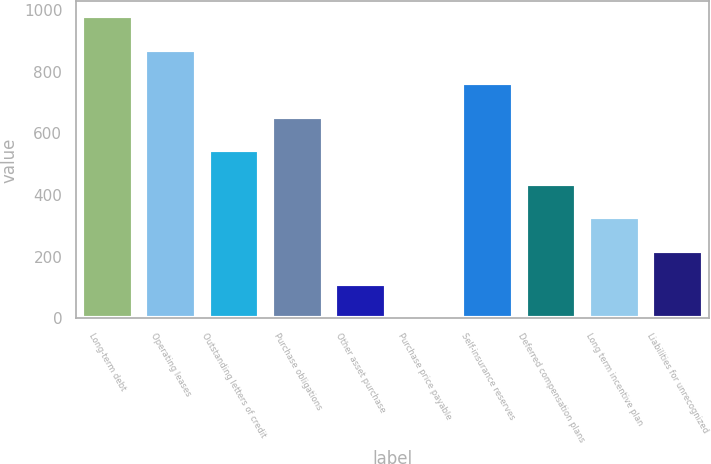Convert chart. <chart><loc_0><loc_0><loc_500><loc_500><bar_chart><fcel>Long-term debt<fcel>Operating leases<fcel>Outstanding letters of credit<fcel>Purchase obligations<fcel>Other asset purchase<fcel>Purchase price payable<fcel>Self-insurance reserves<fcel>Deferred compensation plans<fcel>Long term incentive plan<fcel>Liabilities for unrecognized<nl><fcel>979.59<fcel>871.08<fcel>545.55<fcel>654.06<fcel>111.51<fcel>3<fcel>762.57<fcel>437.04<fcel>328.53<fcel>220.02<nl></chart> 